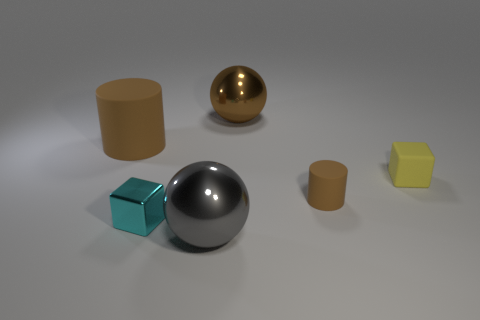There is a metallic object that is the same color as the tiny cylinder; what shape is it?
Provide a succinct answer. Sphere. What is the size of the other rubber cylinder that is the same color as the big cylinder?
Provide a succinct answer. Small. What shape is the large rubber object?
Offer a terse response. Cylinder. The rubber object that is behind the cube behind the tiny brown rubber object is what shape?
Provide a succinct answer. Cylinder. Are the small cube that is to the left of the tiny brown matte object and the big gray thing made of the same material?
Provide a succinct answer. Yes. How many gray objects are large metal spheres or tiny cylinders?
Keep it short and to the point. 1. Are there any small spheres that have the same color as the small metallic thing?
Your response must be concise. No. Are there any green blocks made of the same material as the big brown cylinder?
Your answer should be compact. No. What is the shape of the large thing that is on the right side of the cyan object and behind the small brown rubber thing?
Make the answer very short. Sphere. How many tiny objects are either yellow things or matte balls?
Your answer should be very brief. 1. 